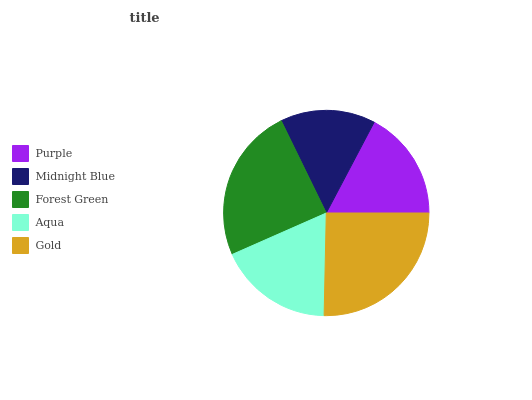Is Midnight Blue the minimum?
Answer yes or no. Yes. Is Gold the maximum?
Answer yes or no. Yes. Is Forest Green the minimum?
Answer yes or no. No. Is Forest Green the maximum?
Answer yes or no. No. Is Forest Green greater than Midnight Blue?
Answer yes or no. Yes. Is Midnight Blue less than Forest Green?
Answer yes or no. Yes. Is Midnight Blue greater than Forest Green?
Answer yes or no. No. Is Forest Green less than Midnight Blue?
Answer yes or no. No. Is Aqua the high median?
Answer yes or no. Yes. Is Aqua the low median?
Answer yes or no. Yes. Is Gold the high median?
Answer yes or no. No. Is Midnight Blue the low median?
Answer yes or no. No. 